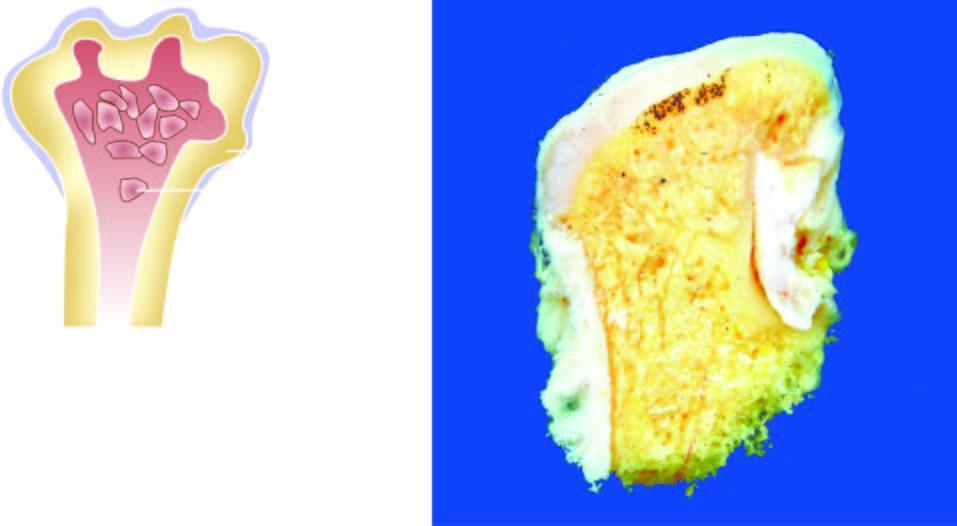do these nodules have cartilaginous caps and inner osseous tissue?
Answer the question using a single word or phrase. Yes 